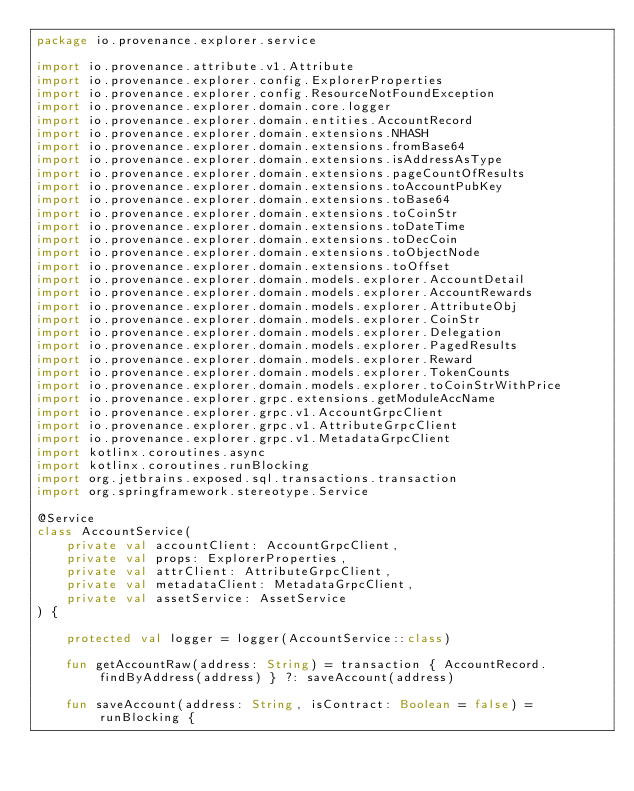Convert code to text. <code><loc_0><loc_0><loc_500><loc_500><_Kotlin_>package io.provenance.explorer.service

import io.provenance.attribute.v1.Attribute
import io.provenance.explorer.config.ExplorerProperties
import io.provenance.explorer.config.ResourceNotFoundException
import io.provenance.explorer.domain.core.logger
import io.provenance.explorer.domain.entities.AccountRecord
import io.provenance.explorer.domain.extensions.NHASH
import io.provenance.explorer.domain.extensions.fromBase64
import io.provenance.explorer.domain.extensions.isAddressAsType
import io.provenance.explorer.domain.extensions.pageCountOfResults
import io.provenance.explorer.domain.extensions.toAccountPubKey
import io.provenance.explorer.domain.extensions.toBase64
import io.provenance.explorer.domain.extensions.toCoinStr
import io.provenance.explorer.domain.extensions.toDateTime
import io.provenance.explorer.domain.extensions.toDecCoin
import io.provenance.explorer.domain.extensions.toObjectNode
import io.provenance.explorer.domain.extensions.toOffset
import io.provenance.explorer.domain.models.explorer.AccountDetail
import io.provenance.explorer.domain.models.explorer.AccountRewards
import io.provenance.explorer.domain.models.explorer.AttributeObj
import io.provenance.explorer.domain.models.explorer.CoinStr
import io.provenance.explorer.domain.models.explorer.Delegation
import io.provenance.explorer.domain.models.explorer.PagedResults
import io.provenance.explorer.domain.models.explorer.Reward
import io.provenance.explorer.domain.models.explorer.TokenCounts
import io.provenance.explorer.domain.models.explorer.toCoinStrWithPrice
import io.provenance.explorer.grpc.extensions.getModuleAccName
import io.provenance.explorer.grpc.v1.AccountGrpcClient
import io.provenance.explorer.grpc.v1.AttributeGrpcClient
import io.provenance.explorer.grpc.v1.MetadataGrpcClient
import kotlinx.coroutines.async
import kotlinx.coroutines.runBlocking
import org.jetbrains.exposed.sql.transactions.transaction
import org.springframework.stereotype.Service

@Service
class AccountService(
    private val accountClient: AccountGrpcClient,
    private val props: ExplorerProperties,
    private val attrClient: AttributeGrpcClient,
    private val metadataClient: MetadataGrpcClient,
    private val assetService: AssetService
) {

    protected val logger = logger(AccountService::class)

    fun getAccountRaw(address: String) = transaction { AccountRecord.findByAddress(address) } ?: saveAccount(address)

    fun saveAccount(address: String, isContract: Boolean = false) = runBlocking {</code> 